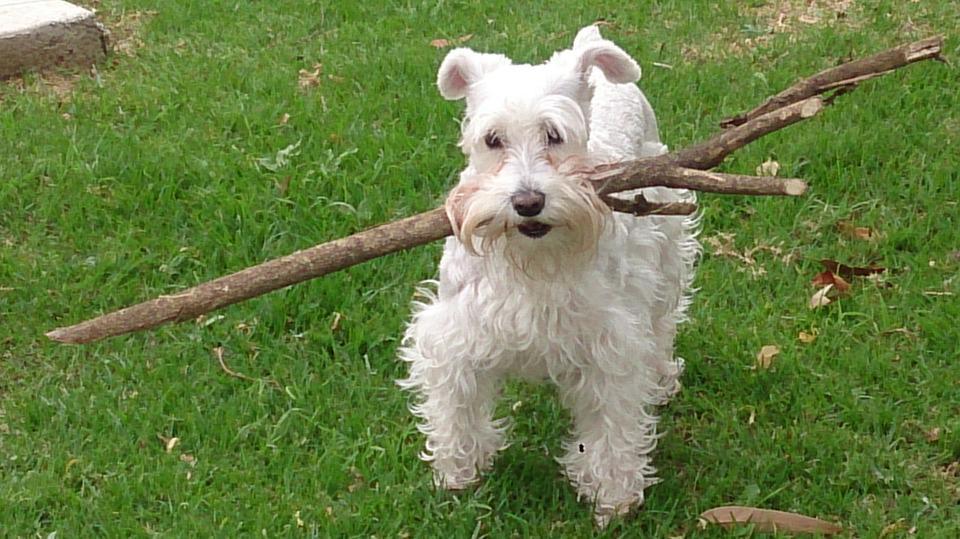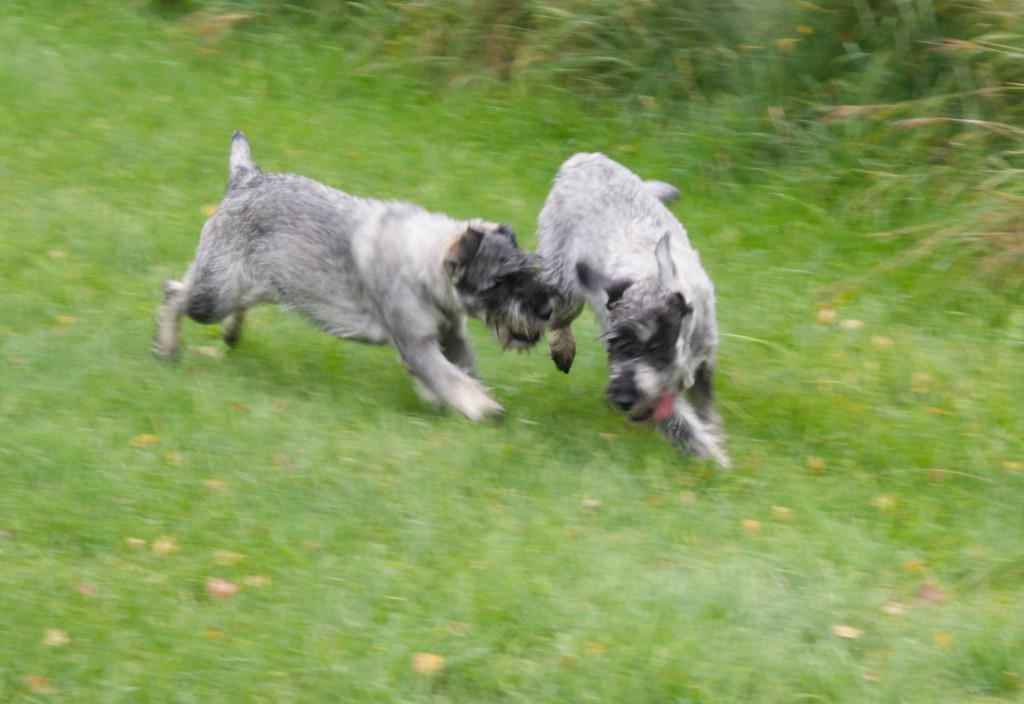The first image is the image on the left, the second image is the image on the right. For the images shown, is this caption "In one of the images there is a single dog that is holding something in its mouth and in the other there are two dogs playing." true? Answer yes or no. Yes. 